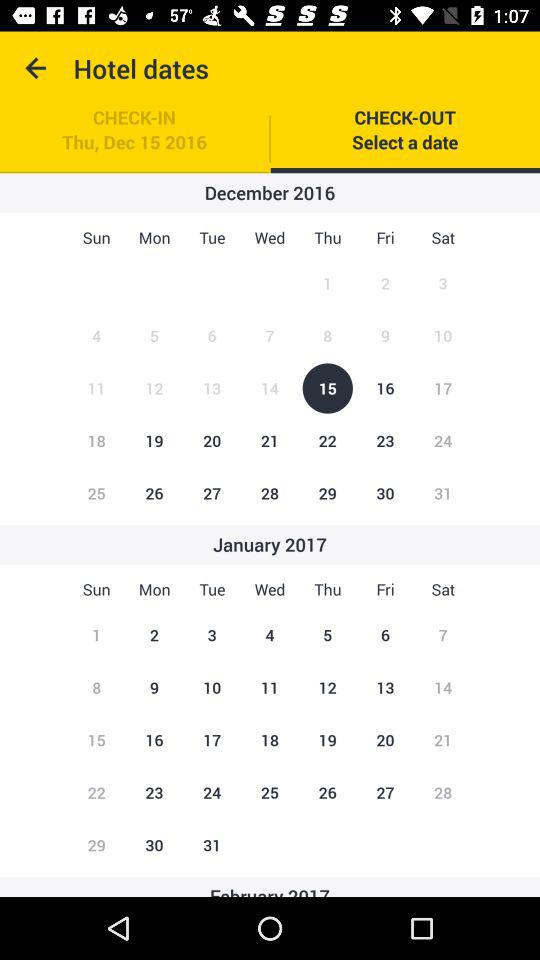What month's date has been selected for check-in? The selected month's date for check-in is December 2016. 